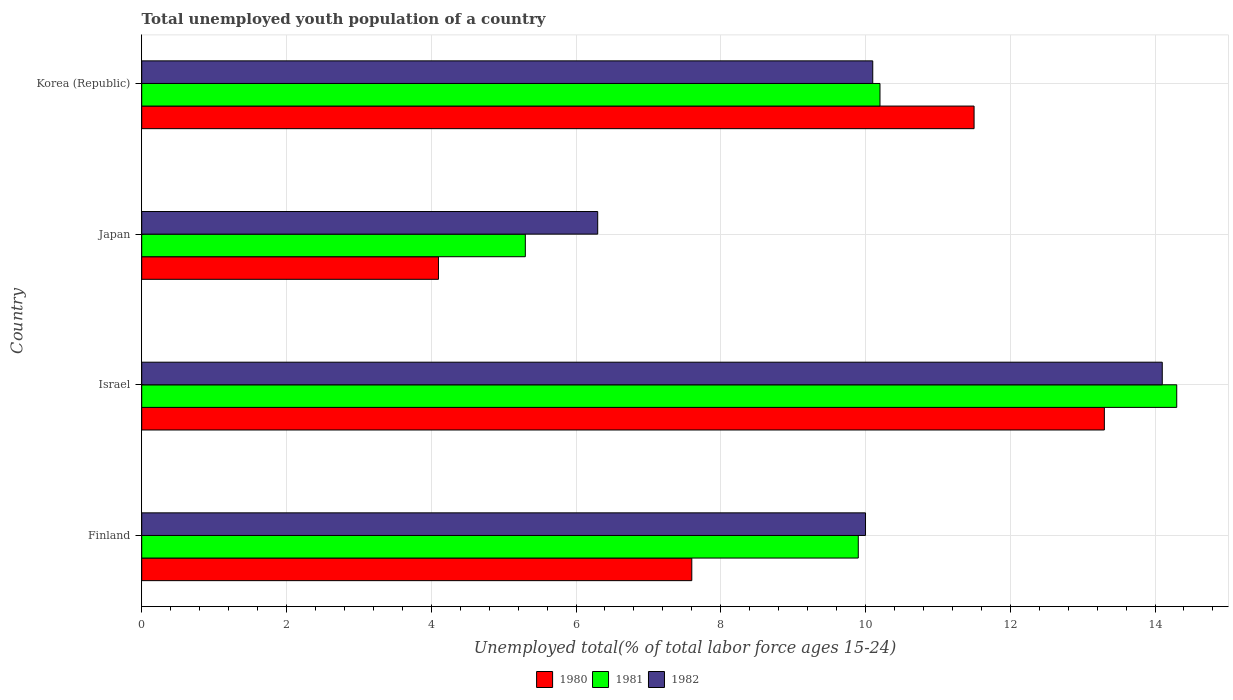How many different coloured bars are there?
Your answer should be very brief. 3. Are the number of bars per tick equal to the number of legend labels?
Your answer should be compact. Yes. How many bars are there on the 1st tick from the bottom?
Your answer should be compact. 3. In how many cases, is the number of bars for a given country not equal to the number of legend labels?
Your answer should be very brief. 0. What is the percentage of total unemployed youth population of a country in 1981 in Finland?
Offer a very short reply. 9.9. Across all countries, what is the maximum percentage of total unemployed youth population of a country in 1982?
Give a very brief answer. 14.1. Across all countries, what is the minimum percentage of total unemployed youth population of a country in 1982?
Your answer should be very brief. 6.3. In which country was the percentage of total unemployed youth population of a country in 1980 minimum?
Your answer should be compact. Japan. What is the total percentage of total unemployed youth population of a country in 1982 in the graph?
Give a very brief answer. 40.5. What is the difference between the percentage of total unemployed youth population of a country in 1981 in Finland and that in Japan?
Provide a succinct answer. 4.6. What is the difference between the percentage of total unemployed youth population of a country in 1980 in Finland and the percentage of total unemployed youth population of a country in 1982 in Korea (Republic)?
Ensure brevity in your answer.  -2.5. What is the average percentage of total unemployed youth population of a country in 1982 per country?
Your answer should be very brief. 10.13. What is the difference between the percentage of total unemployed youth population of a country in 1981 and percentage of total unemployed youth population of a country in 1980 in Korea (Republic)?
Ensure brevity in your answer.  -1.3. In how many countries, is the percentage of total unemployed youth population of a country in 1982 greater than 7.2 %?
Provide a succinct answer. 3. What is the ratio of the percentage of total unemployed youth population of a country in 1980 in Israel to that in Japan?
Give a very brief answer. 3.24. Is the percentage of total unemployed youth population of a country in 1981 in Finland less than that in Japan?
Your response must be concise. No. What is the difference between the highest and the second highest percentage of total unemployed youth population of a country in 1981?
Your response must be concise. 4.1. What is the difference between the highest and the lowest percentage of total unemployed youth population of a country in 1982?
Your response must be concise. 7.8. Is it the case that in every country, the sum of the percentage of total unemployed youth population of a country in 1982 and percentage of total unemployed youth population of a country in 1981 is greater than the percentage of total unemployed youth population of a country in 1980?
Ensure brevity in your answer.  Yes. Are all the bars in the graph horizontal?
Your answer should be very brief. Yes. What is the difference between two consecutive major ticks on the X-axis?
Your answer should be compact. 2. Does the graph contain grids?
Your response must be concise. Yes. How many legend labels are there?
Make the answer very short. 3. How are the legend labels stacked?
Give a very brief answer. Horizontal. What is the title of the graph?
Offer a very short reply. Total unemployed youth population of a country. Does "2006" appear as one of the legend labels in the graph?
Provide a short and direct response. No. What is the label or title of the X-axis?
Ensure brevity in your answer.  Unemployed total(% of total labor force ages 15-24). What is the Unemployed total(% of total labor force ages 15-24) in 1980 in Finland?
Your answer should be compact. 7.6. What is the Unemployed total(% of total labor force ages 15-24) in 1981 in Finland?
Your answer should be compact. 9.9. What is the Unemployed total(% of total labor force ages 15-24) in 1980 in Israel?
Offer a terse response. 13.3. What is the Unemployed total(% of total labor force ages 15-24) of 1981 in Israel?
Your response must be concise. 14.3. What is the Unemployed total(% of total labor force ages 15-24) in 1982 in Israel?
Your answer should be very brief. 14.1. What is the Unemployed total(% of total labor force ages 15-24) of 1980 in Japan?
Offer a terse response. 4.1. What is the Unemployed total(% of total labor force ages 15-24) of 1981 in Japan?
Provide a succinct answer. 5.3. What is the Unemployed total(% of total labor force ages 15-24) of 1982 in Japan?
Make the answer very short. 6.3. What is the Unemployed total(% of total labor force ages 15-24) in 1980 in Korea (Republic)?
Provide a succinct answer. 11.5. What is the Unemployed total(% of total labor force ages 15-24) in 1981 in Korea (Republic)?
Provide a short and direct response. 10.2. What is the Unemployed total(% of total labor force ages 15-24) in 1982 in Korea (Republic)?
Ensure brevity in your answer.  10.1. Across all countries, what is the maximum Unemployed total(% of total labor force ages 15-24) in 1980?
Keep it short and to the point. 13.3. Across all countries, what is the maximum Unemployed total(% of total labor force ages 15-24) in 1981?
Keep it short and to the point. 14.3. Across all countries, what is the maximum Unemployed total(% of total labor force ages 15-24) in 1982?
Make the answer very short. 14.1. Across all countries, what is the minimum Unemployed total(% of total labor force ages 15-24) in 1980?
Provide a succinct answer. 4.1. Across all countries, what is the minimum Unemployed total(% of total labor force ages 15-24) of 1981?
Keep it short and to the point. 5.3. Across all countries, what is the minimum Unemployed total(% of total labor force ages 15-24) in 1982?
Your response must be concise. 6.3. What is the total Unemployed total(% of total labor force ages 15-24) in 1980 in the graph?
Provide a short and direct response. 36.5. What is the total Unemployed total(% of total labor force ages 15-24) of 1981 in the graph?
Make the answer very short. 39.7. What is the total Unemployed total(% of total labor force ages 15-24) in 1982 in the graph?
Your answer should be compact. 40.5. What is the difference between the Unemployed total(% of total labor force ages 15-24) in 1980 in Finland and that in Japan?
Make the answer very short. 3.5. What is the difference between the Unemployed total(% of total labor force ages 15-24) in 1980 in Finland and that in Korea (Republic)?
Your response must be concise. -3.9. What is the difference between the Unemployed total(% of total labor force ages 15-24) of 1980 in Israel and that in Japan?
Your response must be concise. 9.2. What is the difference between the Unemployed total(% of total labor force ages 15-24) in 1982 in Israel and that in Japan?
Make the answer very short. 7.8. What is the difference between the Unemployed total(% of total labor force ages 15-24) in 1980 in Israel and that in Korea (Republic)?
Provide a short and direct response. 1.8. What is the difference between the Unemployed total(% of total labor force ages 15-24) in 1981 in Israel and that in Korea (Republic)?
Provide a short and direct response. 4.1. What is the difference between the Unemployed total(% of total labor force ages 15-24) of 1981 in Japan and that in Korea (Republic)?
Offer a very short reply. -4.9. What is the difference between the Unemployed total(% of total labor force ages 15-24) in 1982 in Japan and that in Korea (Republic)?
Make the answer very short. -3.8. What is the difference between the Unemployed total(% of total labor force ages 15-24) in 1980 in Finland and the Unemployed total(% of total labor force ages 15-24) in 1981 in Israel?
Your answer should be very brief. -6.7. What is the difference between the Unemployed total(% of total labor force ages 15-24) in 1980 in Finland and the Unemployed total(% of total labor force ages 15-24) in 1982 in Korea (Republic)?
Ensure brevity in your answer.  -2.5. What is the difference between the Unemployed total(% of total labor force ages 15-24) in 1980 in Israel and the Unemployed total(% of total labor force ages 15-24) in 1981 in Japan?
Give a very brief answer. 8. What is the difference between the Unemployed total(% of total labor force ages 15-24) of 1980 in Israel and the Unemployed total(% of total labor force ages 15-24) of 1982 in Japan?
Your response must be concise. 7. What is the difference between the Unemployed total(% of total labor force ages 15-24) of 1981 in Israel and the Unemployed total(% of total labor force ages 15-24) of 1982 in Japan?
Your response must be concise. 8. What is the difference between the Unemployed total(% of total labor force ages 15-24) in 1980 in Israel and the Unemployed total(% of total labor force ages 15-24) in 1982 in Korea (Republic)?
Your answer should be compact. 3.2. What is the difference between the Unemployed total(% of total labor force ages 15-24) in 1981 in Israel and the Unemployed total(% of total labor force ages 15-24) in 1982 in Korea (Republic)?
Provide a short and direct response. 4.2. What is the difference between the Unemployed total(% of total labor force ages 15-24) of 1981 in Japan and the Unemployed total(% of total labor force ages 15-24) of 1982 in Korea (Republic)?
Provide a short and direct response. -4.8. What is the average Unemployed total(% of total labor force ages 15-24) in 1980 per country?
Ensure brevity in your answer.  9.12. What is the average Unemployed total(% of total labor force ages 15-24) of 1981 per country?
Your response must be concise. 9.93. What is the average Unemployed total(% of total labor force ages 15-24) in 1982 per country?
Offer a terse response. 10.12. What is the difference between the Unemployed total(% of total labor force ages 15-24) in 1980 and Unemployed total(% of total labor force ages 15-24) in 1982 in Finland?
Ensure brevity in your answer.  -2.4. What is the difference between the Unemployed total(% of total labor force ages 15-24) of 1981 and Unemployed total(% of total labor force ages 15-24) of 1982 in Finland?
Your response must be concise. -0.1. What is the difference between the Unemployed total(% of total labor force ages 15-24) in 1980 and Unemployed total(% of total labor force ages 15-24) in 1982 in Israel?
Offer a very short reply. -0.8. What is the difference between the Unemployed total(% of total labor force ages 15-24) of 1981 and Unemployed total(% of total labor force ages 15-24) of 1982 in Israel?
Your answer should be very brief. 0.2. What is the ratio of the Unemployed total(% of total labor force ages 15-24) in 1980 in Finland to that in Israel?
Make the answer very short. 0.57. What is the ratio of the Unemployed total(% of total labor force ages 15-24) in 1981 in Finland to that in Israel?
Offer a very short reply. 0.69. What is the ratio of the Unemployed total(% of total labor force ages 15-24) of 1982 in Finland to that in Israel?
Your answer should be very brief. 0.71. What is the ratio of the Unemployed total(% of total labor force ages 15-24) in 1980 in Finland to that in Japan?
Provide a short and direct response. 1.85. What is the ratio of the Unemployed total(% of total labor force ages 15-24) of 1981 in Finland to that in Japan?
Your answer should be very brief. 1.87. What is the ratio of the Unemployed total(% of total labor force ages 15-24) in 1982 in Finland to that in Japan?
Offer a very short reply. 1.59. What is the ratio of the Unemployed total(% of total labor force ages 15-24) of 1980 in Finland to that in Korea (Republic)?
Keep it short and to the point. 0.66. What is the ratio of the Unemployed total(% of total labor force ages 15-24) in 1981 in Finland to that in Korea (Republic)?
Offer a terse response. 0.97. What is the ratio of the Unemployed total(% of total labor force ages 15-24) of 1982 in Finland to that in Korea (Republic)?
Your answer should be compact. 0.99. What is the ratio of the Unemployed total(% of total labor force ages 15-24) in 1980 in Israel to that in Japan?
Your answer should be very brief. 3.24. What is the ratio of the Unemployed total(% of total labor force ages 15-24) of 1981 in Israel to that in Japan?
Offer a terse response. 2.7. What is the ratio of the Unemployed total(% of total labor force ages 15-24) of 1982 in Israel to that in Japan?
Your answer should be very brief. 2.24. What is the ratio of the Unemployed total(% of total labor force ages 15-24) of 1980 in Israel to that in Korea (Republic)?
Give a very brief answer. 1.16. What is the ratio of the Unemployed total(% of total labor force ages 15-24) in 1981 in Israel to that in Korea (Republic)?
Your answer should be compact. 1.4. What is the ratio of the Unemployed total(% of total labor force ages 15-24) in 1982 in Israel to that in Korea (Republic)?
Provide a succinct answer. 1.4. What is the ratio of the Unemployed total(% of total labor force ages 15-24) of 1980 in Japan to that in Korea (Republic)?
Make the answer very short. 0.36. What is the ratio of the Unemployed total(% of total labor force ages 15-24) of 1981 in Japan to that in Korea (Republic)?
Provide a short and direct response. 0.52. What is the ratio of the Unemployed total(% of total labor force ages 15-24) of 1982 in Japan to that in Korea (Republic)?
Offer a very short reply. 0.62. What is the difference between the highest and the second highest Unemployed total(% of total labor force ages 15-24) in 1980?
Your response must be concise. 1.8. What is the difference between the highest and the lowest Unemployed total(% of total labor force ages 15-24) in 1980?
Ensure brevity in your answer.  9.2. What is the difference between the highest and the lowest Unemployed total(% of total labor force ages 15-24) in 1981?
Give a very brief answer. 9. What is the difference between the highest and the lowest Unemployed total(% of total labor force ages 15-24) of 1982?
Your answer should be compact. 7.8. 